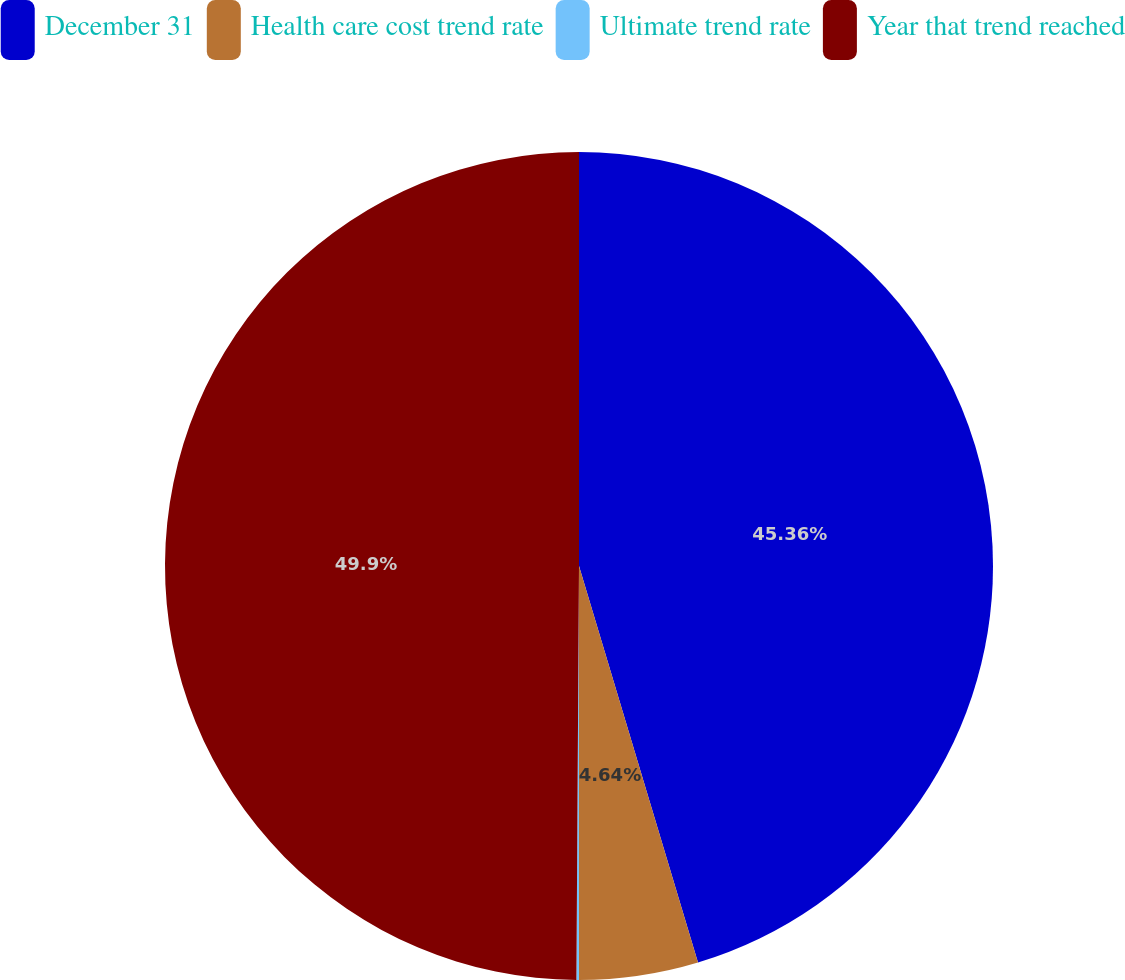<chart> <loc_0><loc_0><loc_500><loc_500><pie_chart><fcel>December 31<fcel>Health care cost trend rate<fcel>Ultimate trend rate<fcel>Year that trend reached<nl><fcel>45.36%<fcel>4.64%<fcel>0.1%<fcel>49.9%<nl></chart> 